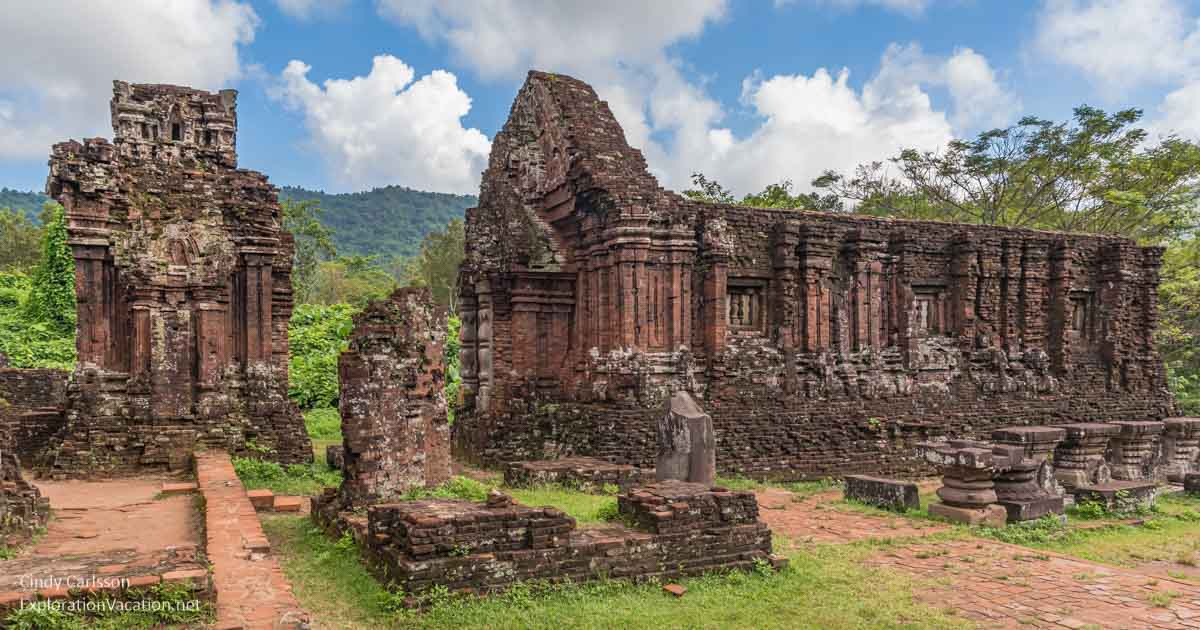How might this site have looked at sunset? As the sun begins its descent, casting a warm, golden glow over the My Son temple complex, the scene transforms into something truly magical. The red bricks of the ancient ruins bask in the soft, amber light, enhancing their textures and contours. Shadows grow longer, adding a touch of mystique to the already serene atmosphere. The surrounding mountains and greenery are bathed in a soft twilight hue, while the evening sky is painted in a gradient of oranges, pinks, and purples. The tranquility of the moment is palpable, with the ruins standing as silent sentinels, their ancient stones seemingly coming alive under the ethereal light of the setting sun. Imagine a realistic scenario where an archaeologist makes a groundbreaking discovery here. During a meticulous excavation at the My Son temple complex, an archaeologist uncovers an exceptionally well-preserved, ancient manuscript hidden beneath the ruins. This manuscript, written in an ancient Cham script, reveals detailed records of the Champa dynasty, including previously unknown rituals, sociopolitical structures, and accounts of significant events. The discovery not only provides invaluable historical insights but also aids in unlocking the linguistic intricacies of the ancient script, offering a deeper understanding and appreciation of the Champa civilization. 